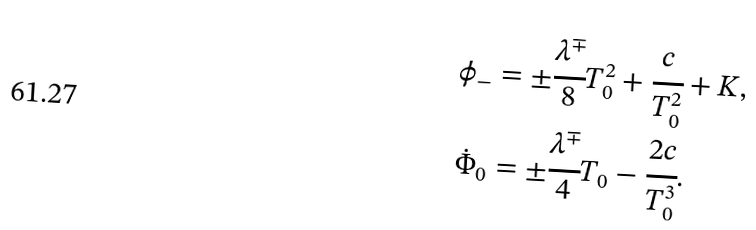Convert formula to latex. <formula><loc_0><loc_0><loc_500><loc_500>\phi _ { - } & = \pm \cfrac { \lambda ^ { \mp } } { 8 } T _ { 0 } ^ { 2 } + \cfrac { c } { T _ { 0 } ^ { 2 } } + K , \\ \dot { \Phi } _ { 0 } & = \pm \cfrac { \lambda ^ { \mp } } { 4 } T _ { 0 } - \cfrac { 2 c } { T _ { 0 } ^ { 3 } } .</formula> 